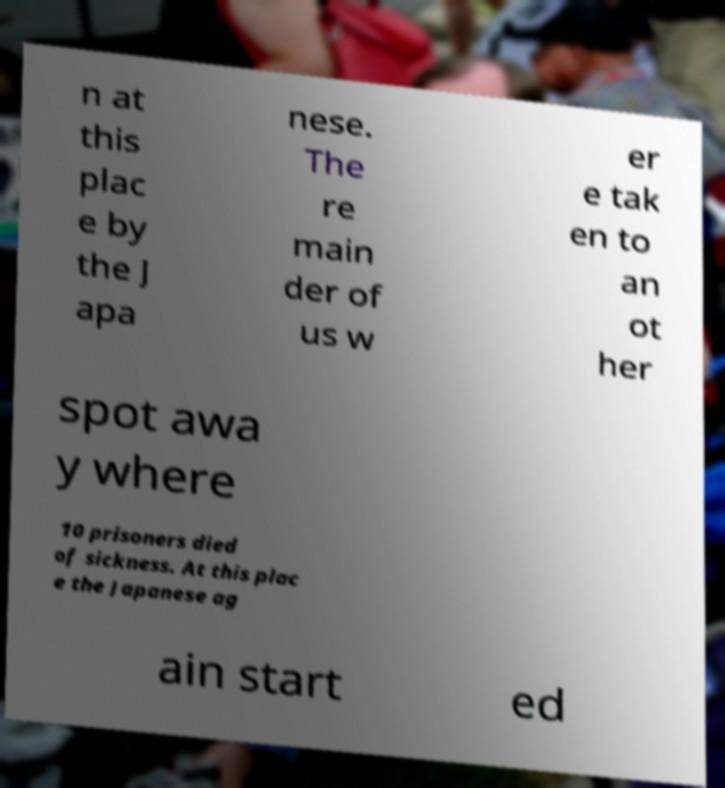Please read and relay the text visible in this image. What does it say? n at this plac e by the J apa nese. The re main der of us w er e tak en to an ot her spot awa y where 10 prisoners died of sickness. At this plac e the Japanese ag ain start ed 